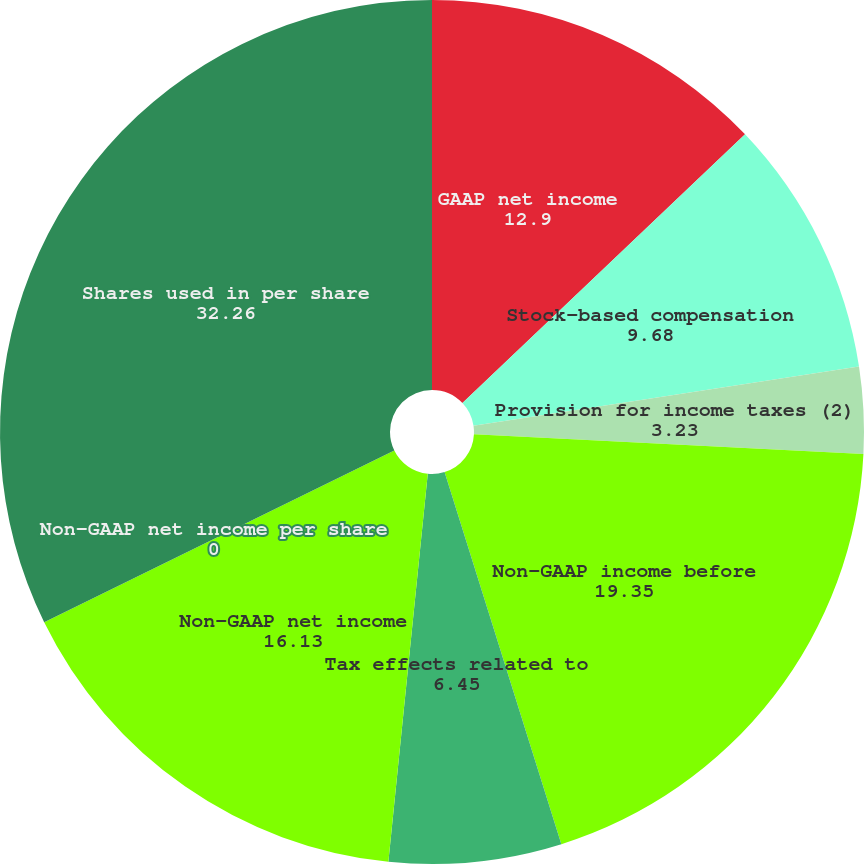Convert chart to OTSL. <chart><loc_0><loc_0><loc_500><loc_500><pie_chart><fcel>GAAP net income<fcel>Stock-based compensation<fcel>Provision for income taxes (2)<fcel>Non-GAAP income before<fcel>Tax effects related to<fcel>Non-GAAP net income<fcel>Non-GAAP net income per share<fcel>Shares used in per share<nl><fcel>12.9%<fcel>9.68%<fcel>3.23%<fcel>19.35%<fcel>6.45%<fcel>16.13%<fcel>0.0%<fcel>32.26%<nl></chart> 